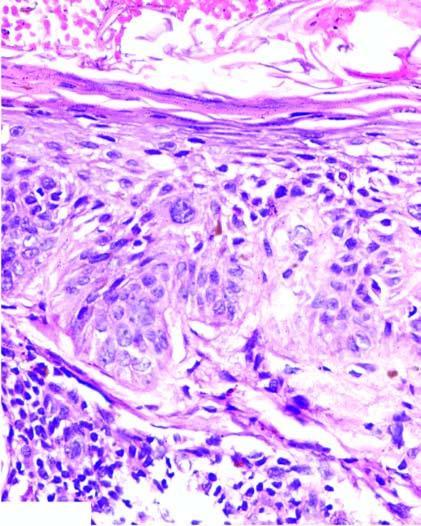s the epidermis thick with loss of rete ridges?
Answer the question using a single word or phrase. Yes 